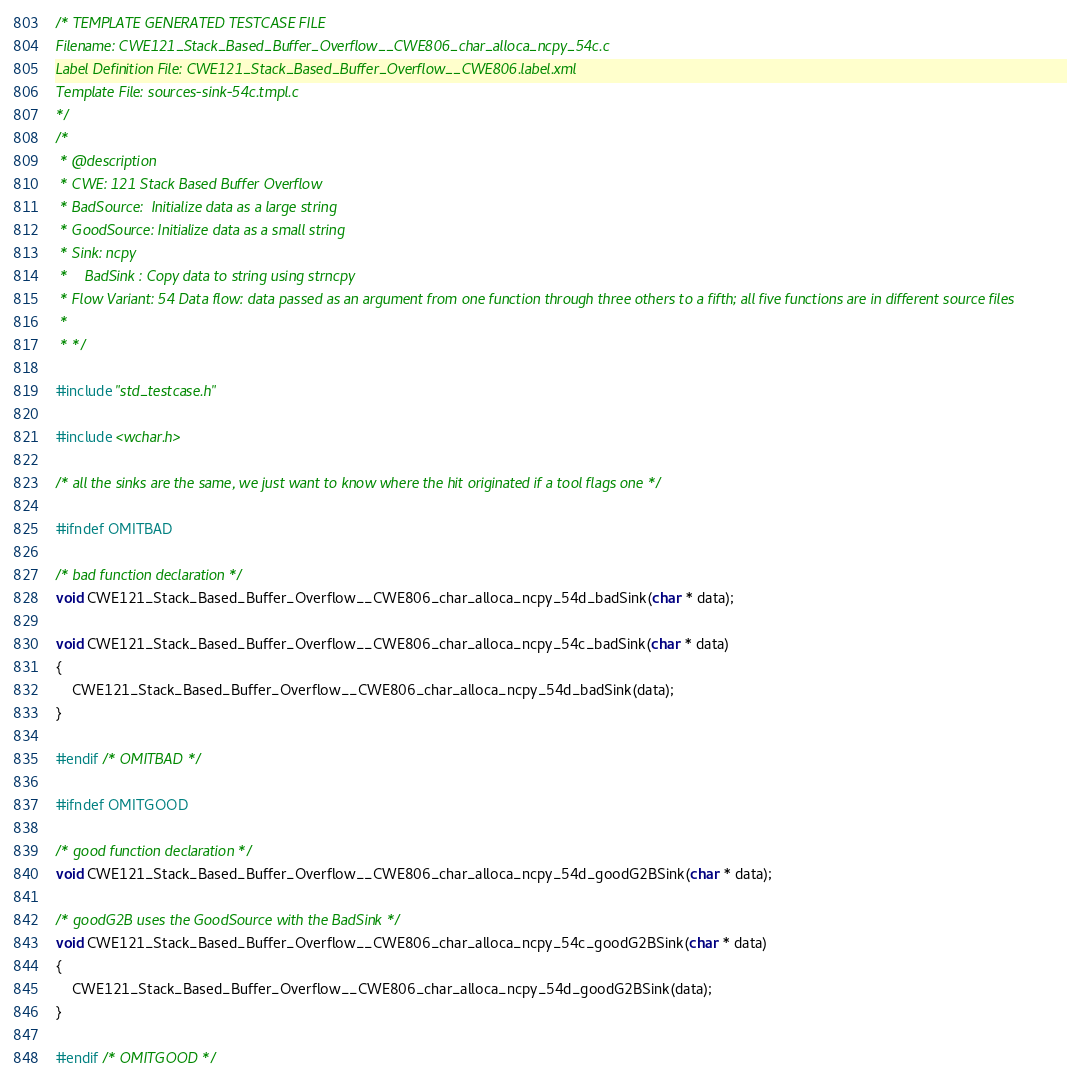Convert code to text. <code><loc_0><loc_0><loc_500><loc_500><_C_>/* TEMPLATE GENERATED TESTCASE FILE
Filename: CWE121_Stack_Based_Buffer_Overflow__CWE806_char_alloca_ncpy_54c.c
Label Definition File: CWE121_Stack_Based_Buffer_Overflow__CWE806.label.xml
Template File: sources-sink-54c.tmpl.c
*/
/*
 * @description
 * CWE: 121 Stack Based Buffer Overflow
 * BadSource:  Initialize data as a large string
 * GoodSource: Initialize data as a small string
 * Sink: ncpy
 *    BadSink : Copy data to string using strncpy
 * Flow Variant: 54 Data flow: data passed as an argument from one function through three others to a fifth; all five functions are in different source files
 *
 * */

#include "std_testcase.h"

#include <wchar.h>

/* all the sinks are the same, we just want to know where the hit originated if a tool flags one */

#ifndef OMITBAD

/* bad function declaration */
void CWE121_Stack_Based_Buffer_Overflow__CWE806_char_alloca_ncpy_54d_badSink(char * data);

void CWE121_Stack_Based_Buffer_Overflow__CWE806_char_alloca_ncpy_54c_badSink(char * data)
{
    CWE121_Stack_Based_Buffer_Overflow__CWE806_char_alloca_ncpy_54d_badSink(data);
}

#endif /* OMITBAD */

#ifndef OMITGOOD

/* good function declaration */
void CWE121_Stack_Based_Buffer_Overflow__CWE806_char_alloca_ncpy_54d_goodG2BSink(char * data);

/* goodG2B uses the GoodSource with the BadSink */
void CWE121_Stack_Based_Buffer_Overflow__CWE806_char_alloca_ncpy_54c_goodG2BSink(char * data)
{
    CWE121_Stack_Based_Buffer_Overflow__CWE806_char_alloca_ncpy_54d_goodG2BSink(data);
}

#endif /* OMITGOOD */
</code> 